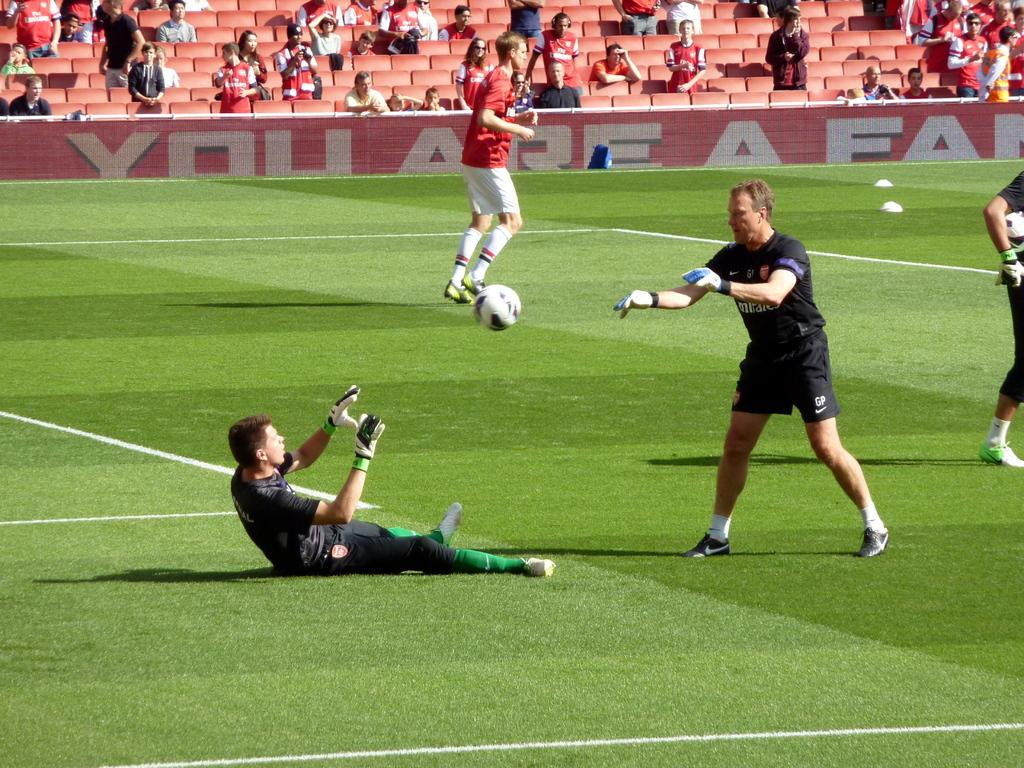<image>
Provide a brief description of the given image. Soccer field with players and a banner in the back that says "You Are A Fan". 